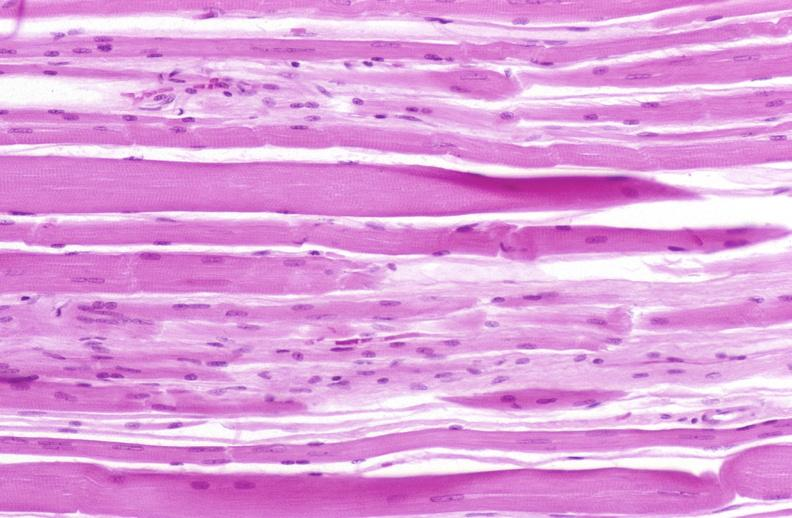s plasma cell present?
Answer the question using a single word or phrase. No 